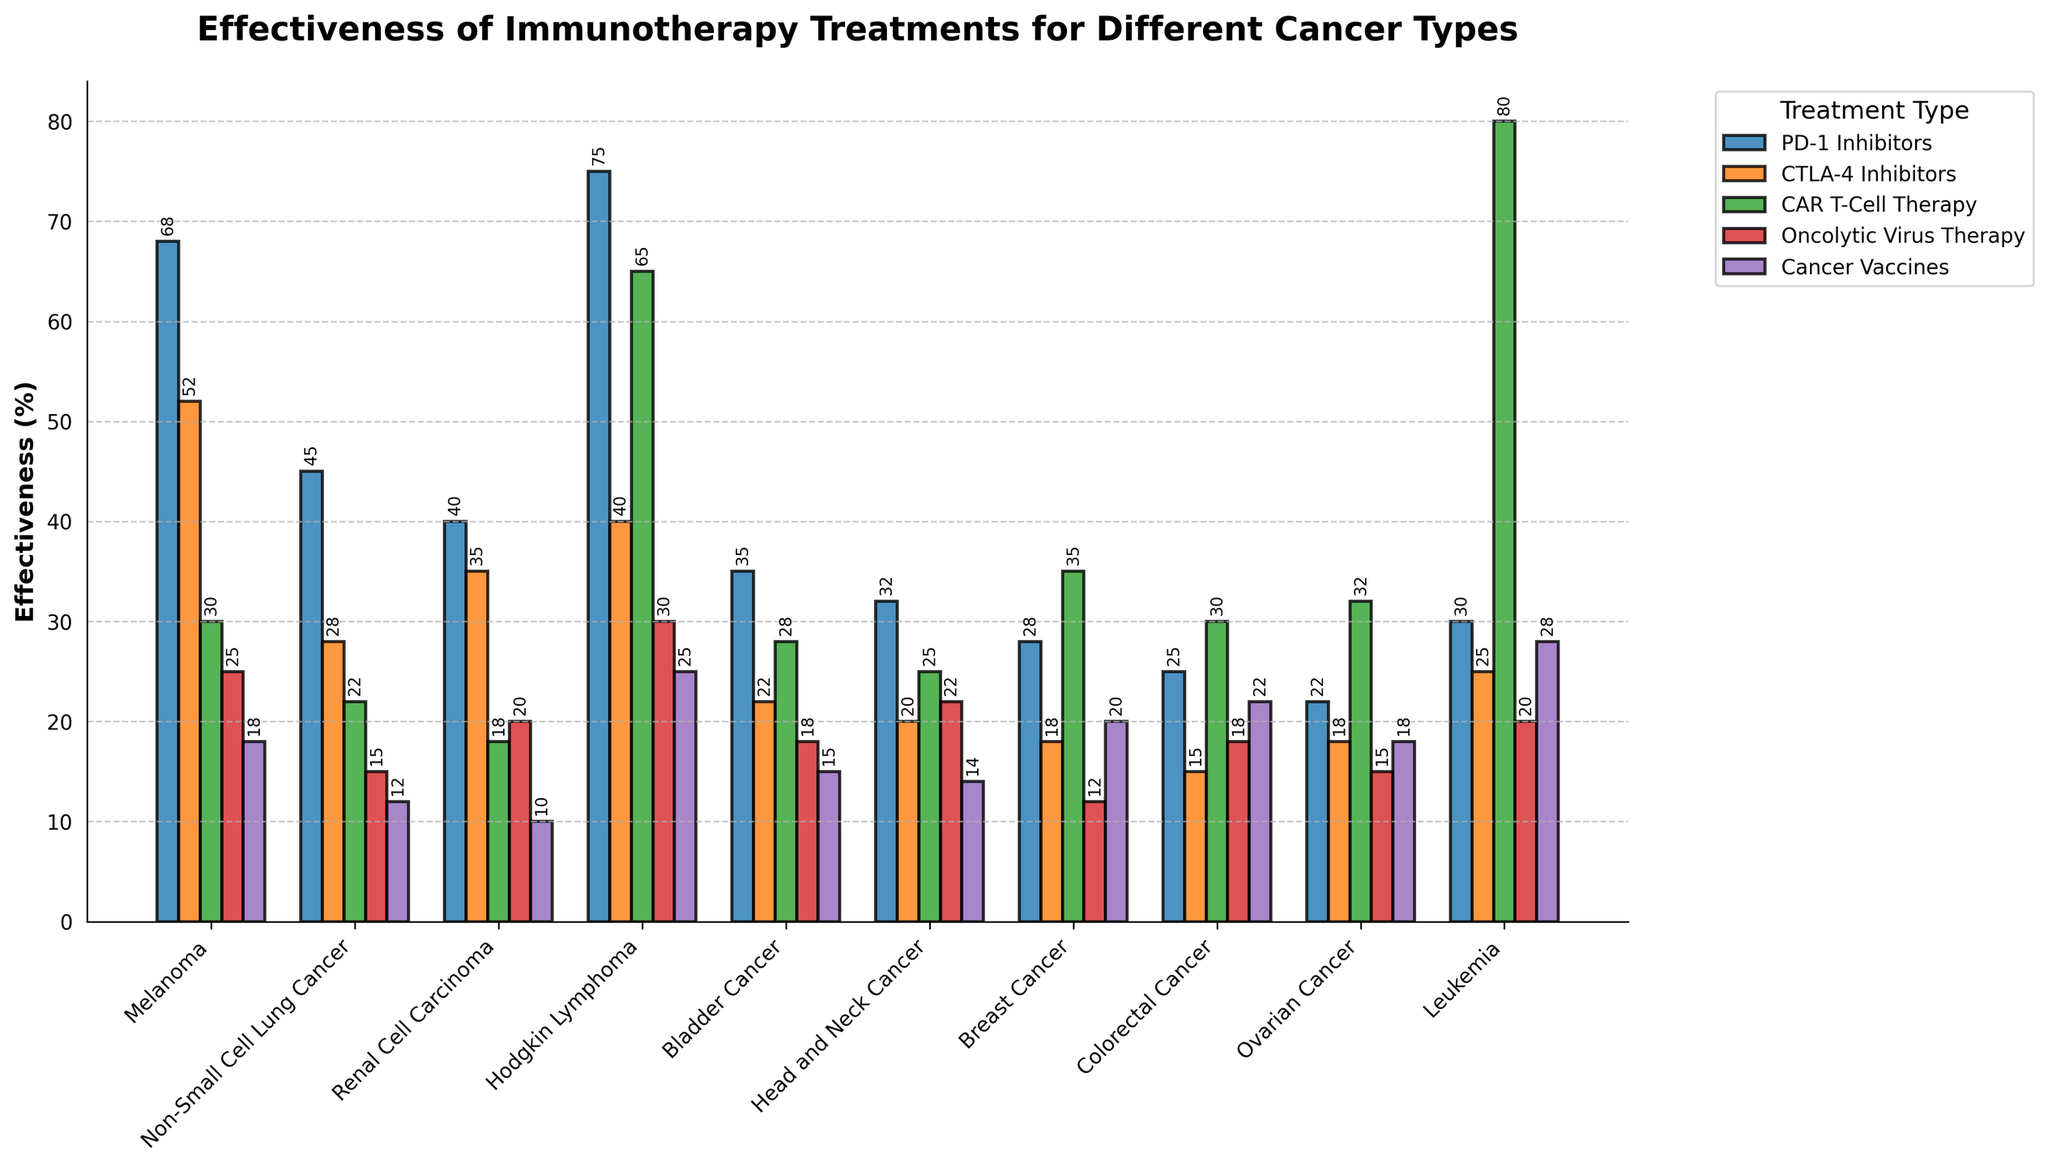What type of cancer has the highest effectiveness for PD-1 Inhibitors? Locate the bar for PD-1 Inhibitors among all cancer types. The tallest bar corresponds to Hodgkin Lymphoma at 75%.
Answer: Hodgkin Lymphoma Compare the effectiveness of CAR T-Cell Therapy between Leukemia and Melanoma. Which one is higher and by how much? Find the heights of the bars for CAR T-Cell Therapy for both Leukemia (80%) and Melanoma (30%). The difference is 80 - 30.
Answer: Leukemia by 50% Which treatment is most effective for Ovarian Cancer? Look at all the bars corresponding to Ovarian Cancer. CAR T-Cell Therapy has the highest effectiveness at 32%.
Answer: CAR T-Cell Therapy What's the average effectiveness of PD-1 Inhibitors across all cancer types? Sum up the effectiveness percentages for PD-1 Inhibitors across all cancer types and divide by the number of cancer types (10). (68+45+40+75+35+32+28+25+22+30) / 10 = 400 / 10.
Answer: 40 Is the effectiveness of Oncolytic Virus Therapy for Hodgkin Lymphoma greater than the effectiveness of Cancer Vaccines for Leukemia? Compare the height of the Oncolytic Virus Therapy bar (30%) for Hodgkin Lymphoma with the Cancer Vaccines bar (28%) for Leukemia.
Answer: Yes For which cancer type do Cancer Vaccines have the lowest effectiveness? Locate the smallest bar among the Cancer Vaccines bars for all cancer types. The lowest is for Renal Cell Carcinoma at 10%.
Answer: Renal Cell Carcinoma How much higher is the effectiveness of PD-1 Inhibitors compared to CTLA-4 Inhibitors for Melanoma? Compare the heights of the bars for PD-1 Inhibitors (68%) and CTLA-4 Inhibitors (52%) for Melanoma. Subtract the two values: 68 - 52.
Answer: 16 Which treatment has the greatest variance in effectiveness across different cancer types? Visually estimate the spread of the bars for each treatment across all cancer types. CAR T-Cell Therapy exhibits the greatest variance, ranging from 18% to 80%.
Answer: CAR T-Cell Therapy Compare the effectiveness of Oncolytic Virus Therapy and Cancer Vaccines for Colorectal Cancer. Which one is more effective? Compare the bar heights for Oncolytic Virus Therapy (18%) and Cancer Vaccines (22%) for Colorectal Cancer.
Answer: Cancer Vaccines 